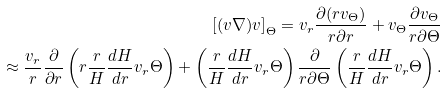<formula> <loc_0><loc_0><loc_500><loc_500>\left [ ( v \nabla ) v \right ] _ { \Theta } = v _ { r } \frac { \partial ( r v _ { \Theta } ) } { r \partial r } + v _ { \Theta } \frac { \partial v _ { \Theta } } { r \partial \Theta } \\ \approx \frac { v _ { r } } { r } \frac { \partial } { \partial r } \left ( r \frac { r } { H } \frac { d H } { d r } v _ { r } \Theta \right ) + \left ( \frac { r } { H } \frac { d H } { d r } v _ { r } \Theta \right ) \frac { \partial } { r \partial \Theta } \left ( \frac { r } { H } \frac { d H } { d r } v _ { r } \Theta \right ) .</formula> 